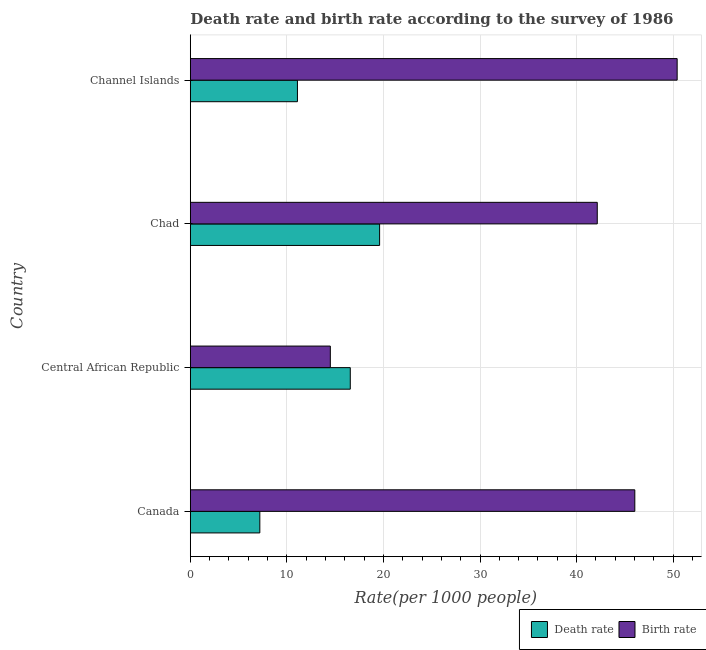Are the number of bars per tick equal to the number of legend labels?
Offer a terse response. Yes. Are the number of bars on each tick of the Y-axis equal?
Offer a terse response. Yes. What is the label of the 2nd group of bars from the top?
Your answer should be very brief. Chad. In how many cases, is the number of bars for a given country not equal to the number of legend labels?
Provide a succinct answer. 0. What is the birth rate in Chad?
Your answer should be very brief. 42.14. Across all countries, what is the maximum death rate?
Keep it short and to the point. 19.6. Across all countries, what is the minimum birth rate?
Offer a very short reply. 14.5. In which country was the death rate maximum?
Provide a short and direct response. Chad. In which country was the death rate minimum?
Keep it short and to the point. Canada. What is the total death rate in the graph?
Keep it short and to the point. 54.46. What is the difference between the death rate in Canada and that in Channel Islands?
Your answer should be very brief. -3.89. What is the difference between the birth rate in Chad and the death rate in Channel Islands?
Provide a short and direct response. 31.05. What is the average birth rate per country?
Provide a short and direct response. 38.27. What is the difference between the birth rate and death rate in Chad?
Your answer should be very brief. 22.54. What is the ratio of the death rate in Central African Republic to that in Channel Islands?
Make the answer very short. 1.49. What is the difference between the highest and the second highest death rate?
Provide a succinct answer. 3.04. What is the difference between the highest and the lowest death rate?
Provide a succinct answer. 12.4. In how many countries, is the birth rate greater than the average birth rate taken over all countries?
Ensure brevity in your answer.  3. What does the 2nd bar from the top in Chad represents?
Offer a very short reply. Death rate. What does the 1st bar from the bottom in Channel Islands represents?
Provide a short and direct response. Death rate. How many bars are there?
Give a very brief answer. 8. What is the difference between two consecutive major ticks on the X-axis?
Give a very brief answer. 10. Does the graph contain grids?
Offer a very short reply. Yes. Where does the legend appear in the graph?
Provide a short and direct response. Bottom right. How many legend labels are there?
Offer a terse response. 2. What is the title of the graph?
Offer a terse response. Death rate and birth rate according to the survey of 1986. Does "Commercial service exports" appear as one of the legend labels in the graph?
Provide a succinct answer. No. What is the label or title of the X-axis?
Provide a short and direct response. Rate(per 1000 people). What is the label or title of the Y-axis?
Your answer should be very brief. Country. What is the Rate(per 1000 people) in Death rate in Canada?
Make the answer very short. 7.2. What is the Rate(per 1000 people) of Birth rate in Canada?
Offer a very short reply. 46.03. What is the Rate(per 1000 people) of Death rate in Central African Republic?
Your response must be concise. 16.57. What is the Rate(per 1000 people) in Death rate in Chad?
Ensure brevity in your answer.  19.6. What is the Rate(per 1000 people) in Birth rate in Chad?
Ensure brevity in your answer.  42.14. What is the Rate(per 1000 people) of Death rate in Channel Islands?
Provide a short and direct response. 11.09. What is the Rate(per 1000 people) in Birth rate in Channel Islands?
Provide a succinct answer. 50.41. Across all countries, what is the maximum Rate(per 1000 people) in Death rate?
Give a very brief answer. 19.6. Across all countries, what is the maximum Rate(per 1000 people) of Birth rate?
Make the answer very short. 50.41. Across all countries, what is the minimum Rate(per 1000 people) of Death rate?
Offer a terse response. 7.2. What is the total Rate(per 1000 people) of Death rate in the graph?
Keep it short and to the point. 54.46. What is the total Rate(per 1000 people) of Birth rate in the graph?
Your answer should be compact. 153.08. What is the difference between the Rate(per 1000 people) of Death rate in Canada and that in Central African Republic?
Provide a short and direct response. -9.37. What is the difference between the Rate(per 1000 people) in Birth rate in Canada and that in Central African Republic?
Your answer should be compact. 31.53. What is the difference between the Rate(per 1000 people) of Death rate in Canada and that in Chad?
Provide a succinct answer. -12.4. What is the difference between the Rate(per 1000 people) in Birth rate in Canada and that in Chad?
Your answer should be very brief. 3.89. What is the difference between the Rate(per 1000 people) in Death rate in Canada and that in Channel Islands?
Offer a very short reply. -3.89. What is the difference between the Rate(per 1000 people) of Birth rate in Canada and that in Channel Islands?
Give a very brief answer. -4.38. What is the difference between the Rate(per 1000 people) of Death rate in Central African Republic and that in Chad?
Ensure brevity in your answer.  -3.04. What is the difference between the Rate(per 1000 people) of Birth rate in Central African Republic and that in Chad?
Offer a terse response. -27.64. What is the difference between the Rate(per 1000 people) of Death rate in Central African Republic and that in Channel Islands?
Offer a very short reply. 5.47. What is the difference between the Rate(per 1000 people) of Birth rate in Central African Republic and that in Channel Islands?
Ensure brevity in your answer.  -35.91. What is the difference between the Rate(per 1000 people) of Death rate in Chad and that in Channel Islands?
Make the answer very short. 8.51. What is the difference between the Rate(per 1000 people) of Birth rate in Chad and that in Channel Islands?
Give a very brief answer. -8.27. What is the difference between the Rate(per 1000 people) of Death rate in Canada and the Rate(per 1000 people) of Birth rate in Chad?
Give a very brief answer. -34.94. What is the difference between the Rate(per 1000 people) in Death rate in Canada and the Rate(per 1000 people) in Birth rate in Channel Islands?
Your answer should be very brief. -43.21. What is the difference between the Rate(per 1000 people) in Death rate in Central African Republic and the Rate(per 1000 people) in Birth rate in Chad?
Your answer should be very brief. -25.57. What is the difference between the Rate(per 1000 people) of Death rate in Central African Republic and the Rate(per 1000 people) of Birth rate in Channel Islands?
Your response must be concise. -33.85. What is the difference between the Rate(per 1000 people) in Death rate in Chad and the Rate(per 1000 people) in Birth rate in Channel Islands?
Make the answer very short. -30.81. What is the average Rate(per 1000 people) in Death rate per country?
Offer a terse response. 13.62. What is the average Rate(per 1000 people) of Birth rate per country?
Give a very brief answer. 38.27. What is the difference between the Rate(per 1000 people) of Death rate and Rate(per 1000 people) of Birth rate in Canada?
Give a very brief answer. -38.83. What is the difference between the Rate(per 1000 people) of Death rate and Rate(per 1000 people) of Birth rate in Central African Republic?
Offer a very short reply. 2.07. What is the difference between the Rate(per 1000 people) in Death rate and Rate(per 1000 people) in Birth rate in Chad?
Your answer should be very brief. -22.54. What is the difference between the Rate(per 1000 people) of Death rate and Rate(per 1000 people) of Birth rate in Channel Islands?
Ensure brevity in your answer.  -39.32. What is the ratio of the Rate(per 1000 people) in Death rate in Canada to that in Central African Republic?
Keep it short and to the point. 0.43. What is the ratio of the Rate(per 1000 people) of Birth rate in Canada to that in Central African Republic?
Make the answer very short. 3.17. What is the ratio of the Rate(per 1000 people) of Death rate in Canada to that in Chad?
Provide a short and direct response. 0.37. What is the ratio of the Rate(per 1000 people) of Birth rate in Canada to that in Chad?
Your response must be concise. 1.09. What is the ratio of the Rate(per 1000 people) of Death rate in Canada to that in Channel Islands?
Offer a very short reply. 0.65. What is the ratio of the Rate(per 1000 people) of Death rate in Central African Republic to that in Chad?
Provide a succinct answer. 0.85. What is the ratio of the Rate(per 1000 people) in Birth rate in Central African Republic to that in Chad?
Keep it short and to the point. 0.34. What is the ratio of the Rate(per 1000 people) of Death rate in Central African Republic to that in Channel Islands?
Make the answer very short. 1.49. What is the ratio of the Rate(per 1000 people) of Birth rate in Central African Republic to that in Channel Islands?
Offer a very short reply. 0.29. What is the ratio of the Rate(per 1000 people) in Death rate in Chad to that in Channel Islands?
Offer a very short reply. 1.77. What is the ratio of the Rate(per 1000 people) in Birth rate in Chad to that in Channel Islands?
Your answer should be very brief. 0.84. What is the difference between the highest and the second highest Rate(per 1000 people) of Death rate?
Offer a terse response. 3.04. What is the difference between the highest and the second highest Rate(per 1000 people) in Birth rate?
Keep it short and to the point. 4.38. What is the difference between the highest and the lowest Rate(per 1000 people) in Death rate?
Give a very brief answer. 12.4. What is the difference between the highest and the lowest Rate(per 1000 people) in Birth rate?
Make the answer very short. 35.91. 